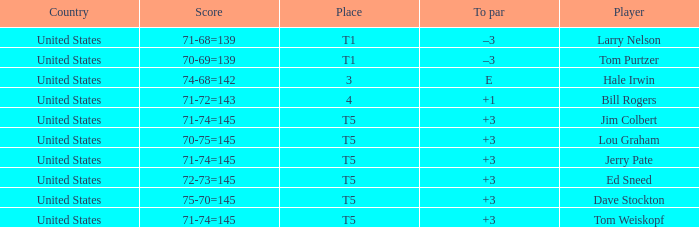Who is the player with a 70-75=145 score? Lou Graham. 